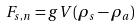<formula> <loc_0><loc_0><loc_500><loc_500>F _ { s , n } = g V ( \rho _ { s } - \rho _ { a } )</formula> 